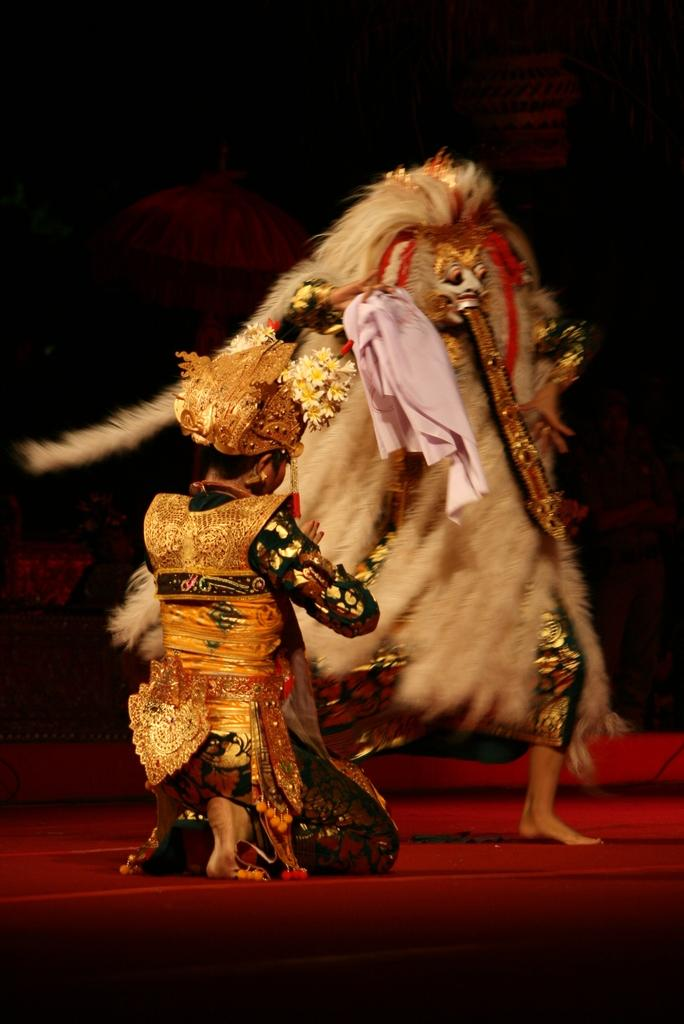How many people are in the image? There are two persons in the image. What are the persons doing in the image? The persons are on the floor. What are the persons wearing in the image? The persons are wearing fancy dresses. What can be observed about the background of the image? The background of the image is dark. What type of music can be heard playing in the background of the image? There is no music present in the image, as it only shows two persons on the floor wearing fancy dresses with a dark background. 